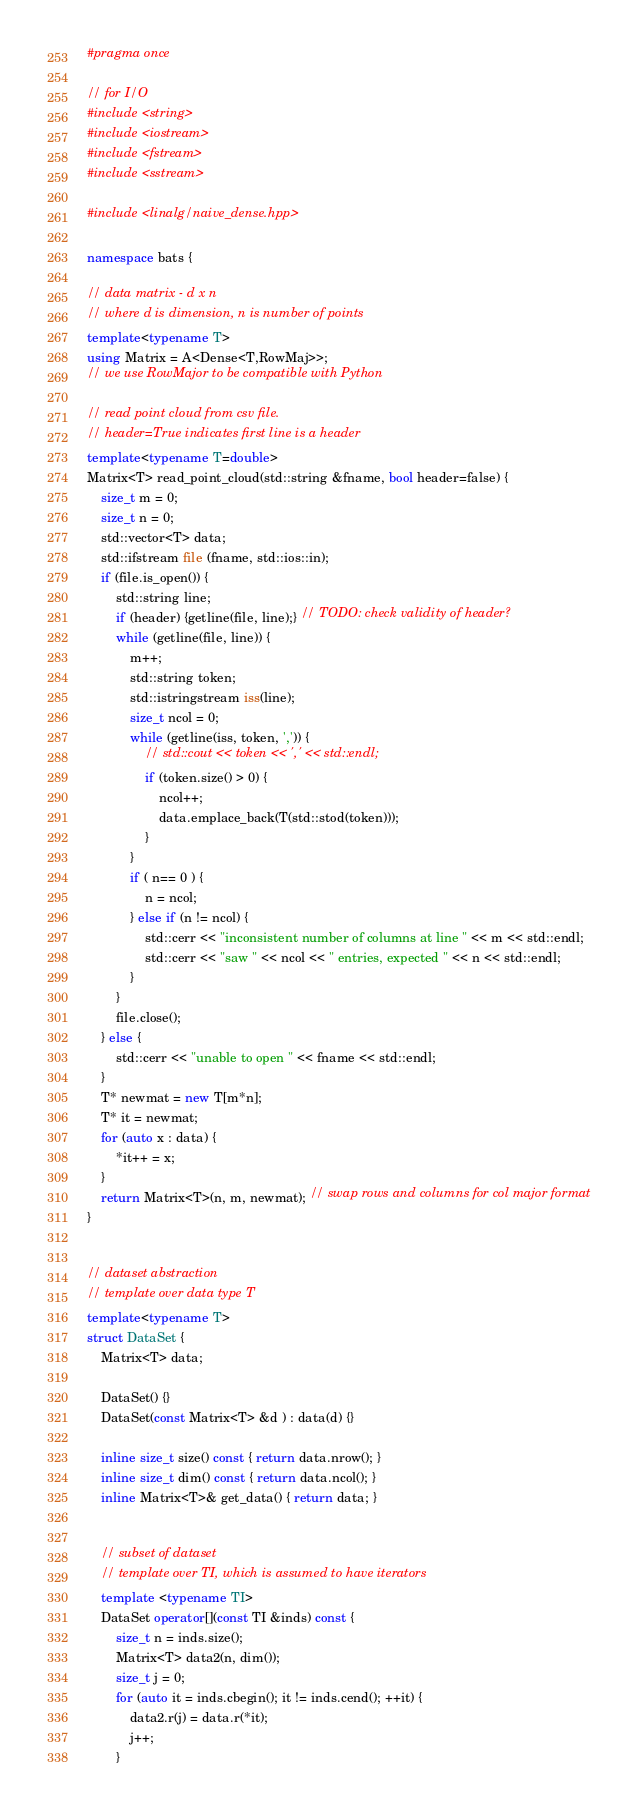<code> <loc_0><loc_0><loc_500><loc_500><_C++_>#pragma once

// for I/O
#include <string>
#include <iostream>
#include <fstream>
#include <sstream>

#include <linalg/naive_dense.hpp>

namespace bats {

// data matrix - d x n
// where d is dimension, n is number of points
template<typename T>
using Matrix = A<Dense<T,RowMaj>>;
// we use RowMajor to be compatible with Python

// read point cloud from csv file.
// header=True indicates first line is a header
template<typename T=double>
Matrix<T> read_point_cloud(std::string &fname, bool header=false) {
	size_t m = 0;
	size_t n = 0;
	std::vector<T> data;
	std::ifstream file (fname, std::ios::in);
	if (file.is_open()) {
		std::string line;
		if (header) {getline(file, line);} // TODO: check validity of header?
		while (getline(file, line)) {
			m++;
			std::string token;
		    std::istringstream iss(line);
			size_t ncol = 0;
			while (getline(iss, token, ',')) {
				// std::cout << token << ',' << std::endl;
				if (token.size() > 0) {
					ncol++;
					data.emplace_back(T(std::stod(token)));
				}
			}
			if ( n== 0 ) {
				n = ncol;
			} else if (n != ncol) {
				std::cerr << "inconsistent number of columns at line " << m << std::endl;
				std::cerr << "saw " << ncol << " entries, expected " << n << std::endl;
			}
		}
		file.close();
	} else {
		std::cerr << "unable to open " << fname << std::endl;
	}
	T* newmat = new T[m*n];
	T* it = newmat;
	for (auto x : data) {
		*it++ = x;
	}
	return Matrix<T>(n, m, newmat); // swap rows and columns for col major format
}


// dataset abstraction
// template over data type T
template<typename T>
struct DataSet {
	Matrix<T> data;

	DataSet() {}
	DataSet(const Matrix<T> &d ) : data(d) {}

	inline size_t size() const { return data.nrow(); }
	inline size_t dim() const { return data.ncol(); }
	inline Matrix<T>& get_data() { return data; }


	// subset of dataset
	// template over TI, which is assumed to have iterators
	template <typename TI>
	DataSet operator[](const TI &inds) const {
		size_t n = inds.size();
		Matrix<T> data2(n, dim());
		size_t j = 0;
		for (auto it = inds.cbegin(); it != inds.cend(); ++it) {
			data2.r(j) = data.r(*it);
			j++;
		}</code> 